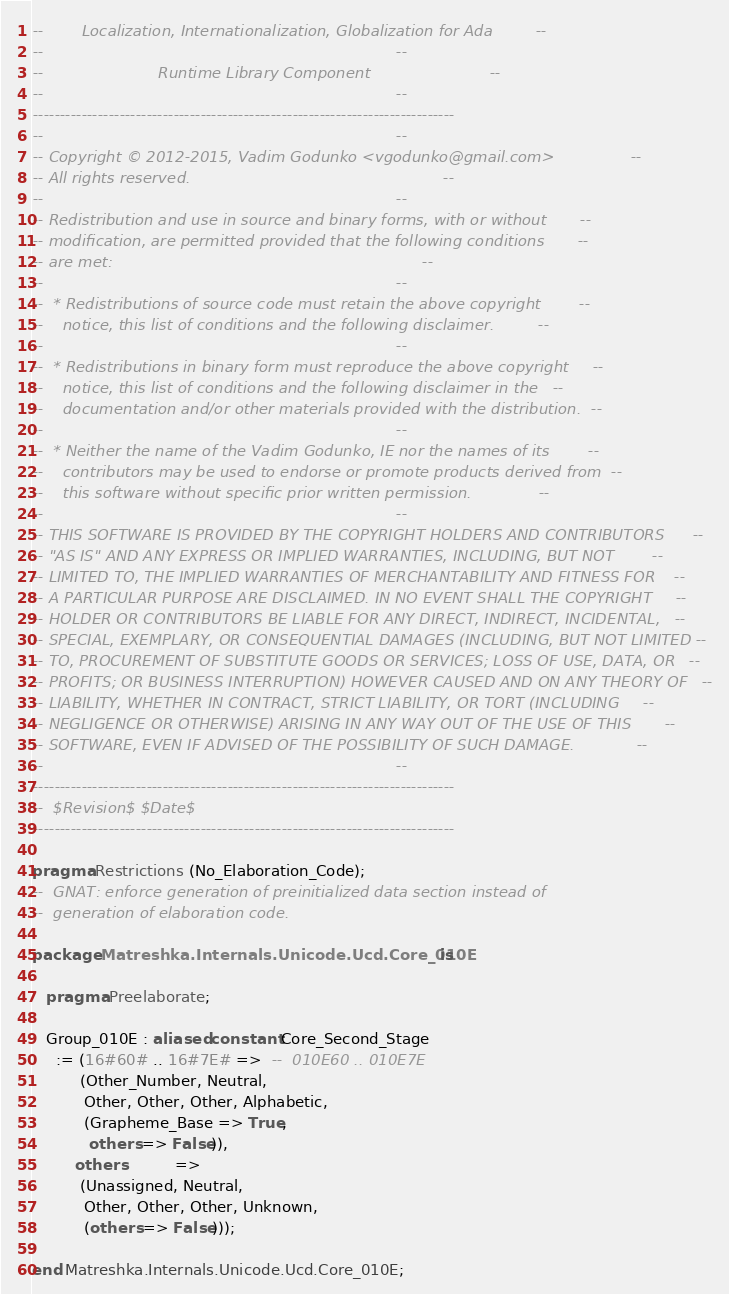<code> <loc_0><loc_0><loc_500><loc_500><_Ada_>--        Localization, Internationalization, Globalization for Ada         --
--                                                                          --
--                        Runtime Library Component                         --
--                                                                          --
------------------------------------------------------------------------------
--                                                                          --
-- Copyright © 2012-2015, Vadim Godunko <vgodunko@gmail.com>                --
-- All rights reserved.                                                     --
--                                                                          --
-- Redistribution and use in source and binary forms, with or without       --
-- modification, are permitted provided that the following conditions       --
-- are met:                                                                 --
--                                                                          --
--  * Redistributions of source code must retain the above copyright        --
--    notice, this list of conditions and the following disclaimer.         --
--                                                                          --
--  * Redistributions in binary form must reproduce the above copyright     --
--    notice, this list of conditions and the following disclaimer in the   --
--    documentation and/or other materials provided with the distribution.  --
--                                                                          --
--  * Neither the name of the Vadim Godunko, IE nor the names of its        --
--    contributors may be used to endorse or promote products derived from  --
--    this software without specific prior written permission.              --
--                                                                          --
-- THIS SOFTWARE IS PROVIDED BY THE COPYRIGHT HOLDERS AND CONTRIBUTORS      --
-- "AS IS" AND ANY EXPRESS OR IMPLIED WARRANTIES, INCLUDING, BUT NOT        --
-- LIMITED TO, THE IMPLIED WARRANTIES OF MERCHANTABILITY AND FITNESS FOR    --
-- A PARTICULAR PURPOSE ARE DISCLAIMED. IN NO EVENT SHALL THE COPYRIGHT     --
-- HOLDER OR CONTRIBUTORS BE LIABLE FOR ANY DIRECT, INDIRECT, INCIDENTAL,   --
-- SPECIAL, EXEMPLARY, OR CONSEQUENTIAL DAMAGES (INCLUDING, BUT NOT LIMITED --
-- TO, PROCUREMENT OF SUBSTITUTE GOODS OR SERVICES; LOSS OF USE, DATA, OR   --
-- PROFITS; OR BUSINESS INTERRUPTION) HOWEVER CAUSED AND ON ANY THEORY OF   --
-- LIABILITY, WHETHER IN CONTRACT, STRICT LIABILITY, OR TORT (INCLUDING     --
-- NEGLIGENCE OR OTHERWISE) ARISING IN ANY WAY OUT OF THE USE OF THIS       --
-- SOFTWARE, EVEN IF ADVISED OF THE POSSIBILITY OF SUCH DAMAGE.             --
--                                                                          --
------------------------------------------------------------------------------
--  $Revision$ $Date$
------------------------------------------------------------------------------

pragma Restrictions (No_Elaboration_Code);
--  GNAT: enforce generation of preinitialized data section instead of
--  generation of elaboration code.

package Matreshka.Internals.Unicode.Ucd.Core_010E is

   pragma Preelaborate;

   Group_010E : aliased constant Core_Second_Stage
     := (16#60# .. 16#7E# =>  --  010E60 .. 010E7E
          (Other_Number, Neutral,
           Other, Other, Other, Alphabetic,
           (Grapheme_Base => True,
            others => False)),
         others           =>
          (Unassigned, Neutral,
           Other, Other, Other, Unknown,
           (others => False)));

end Matreshka.Internals.Unicode.Ucd.Core_010E;
</code> 